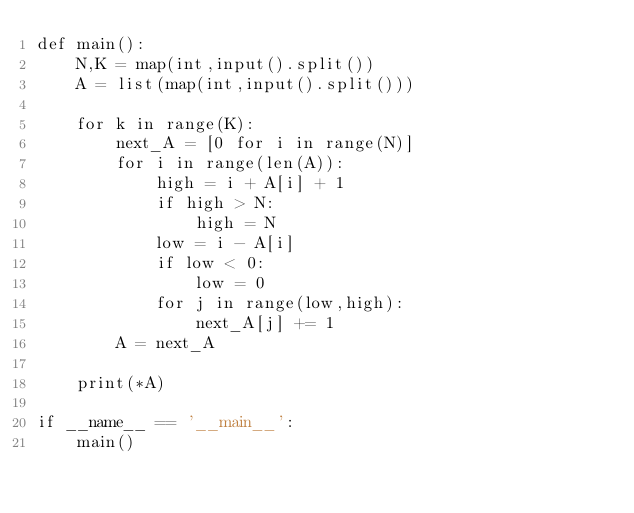Convert code to text. <code><loc_0><loc_0><loc_500><loc_500><_Python_>def main():
    N,K = map(int,input().split())
    A = list(map(int,input().split()))
    
    for k in range(K):
        next_A = [0 for i in range(N)]
        for i in range(len(A)):
            high = i + A[i] + 1
            if high > N:
                high = N
            low = i - A[i]
            if low < 0:
                low = 0
            for j in range(low,high):
                next_A[j] += 1
        A = next_A
    
    print(*A)
    
if __name__ == '__main__':
    main()</code> 